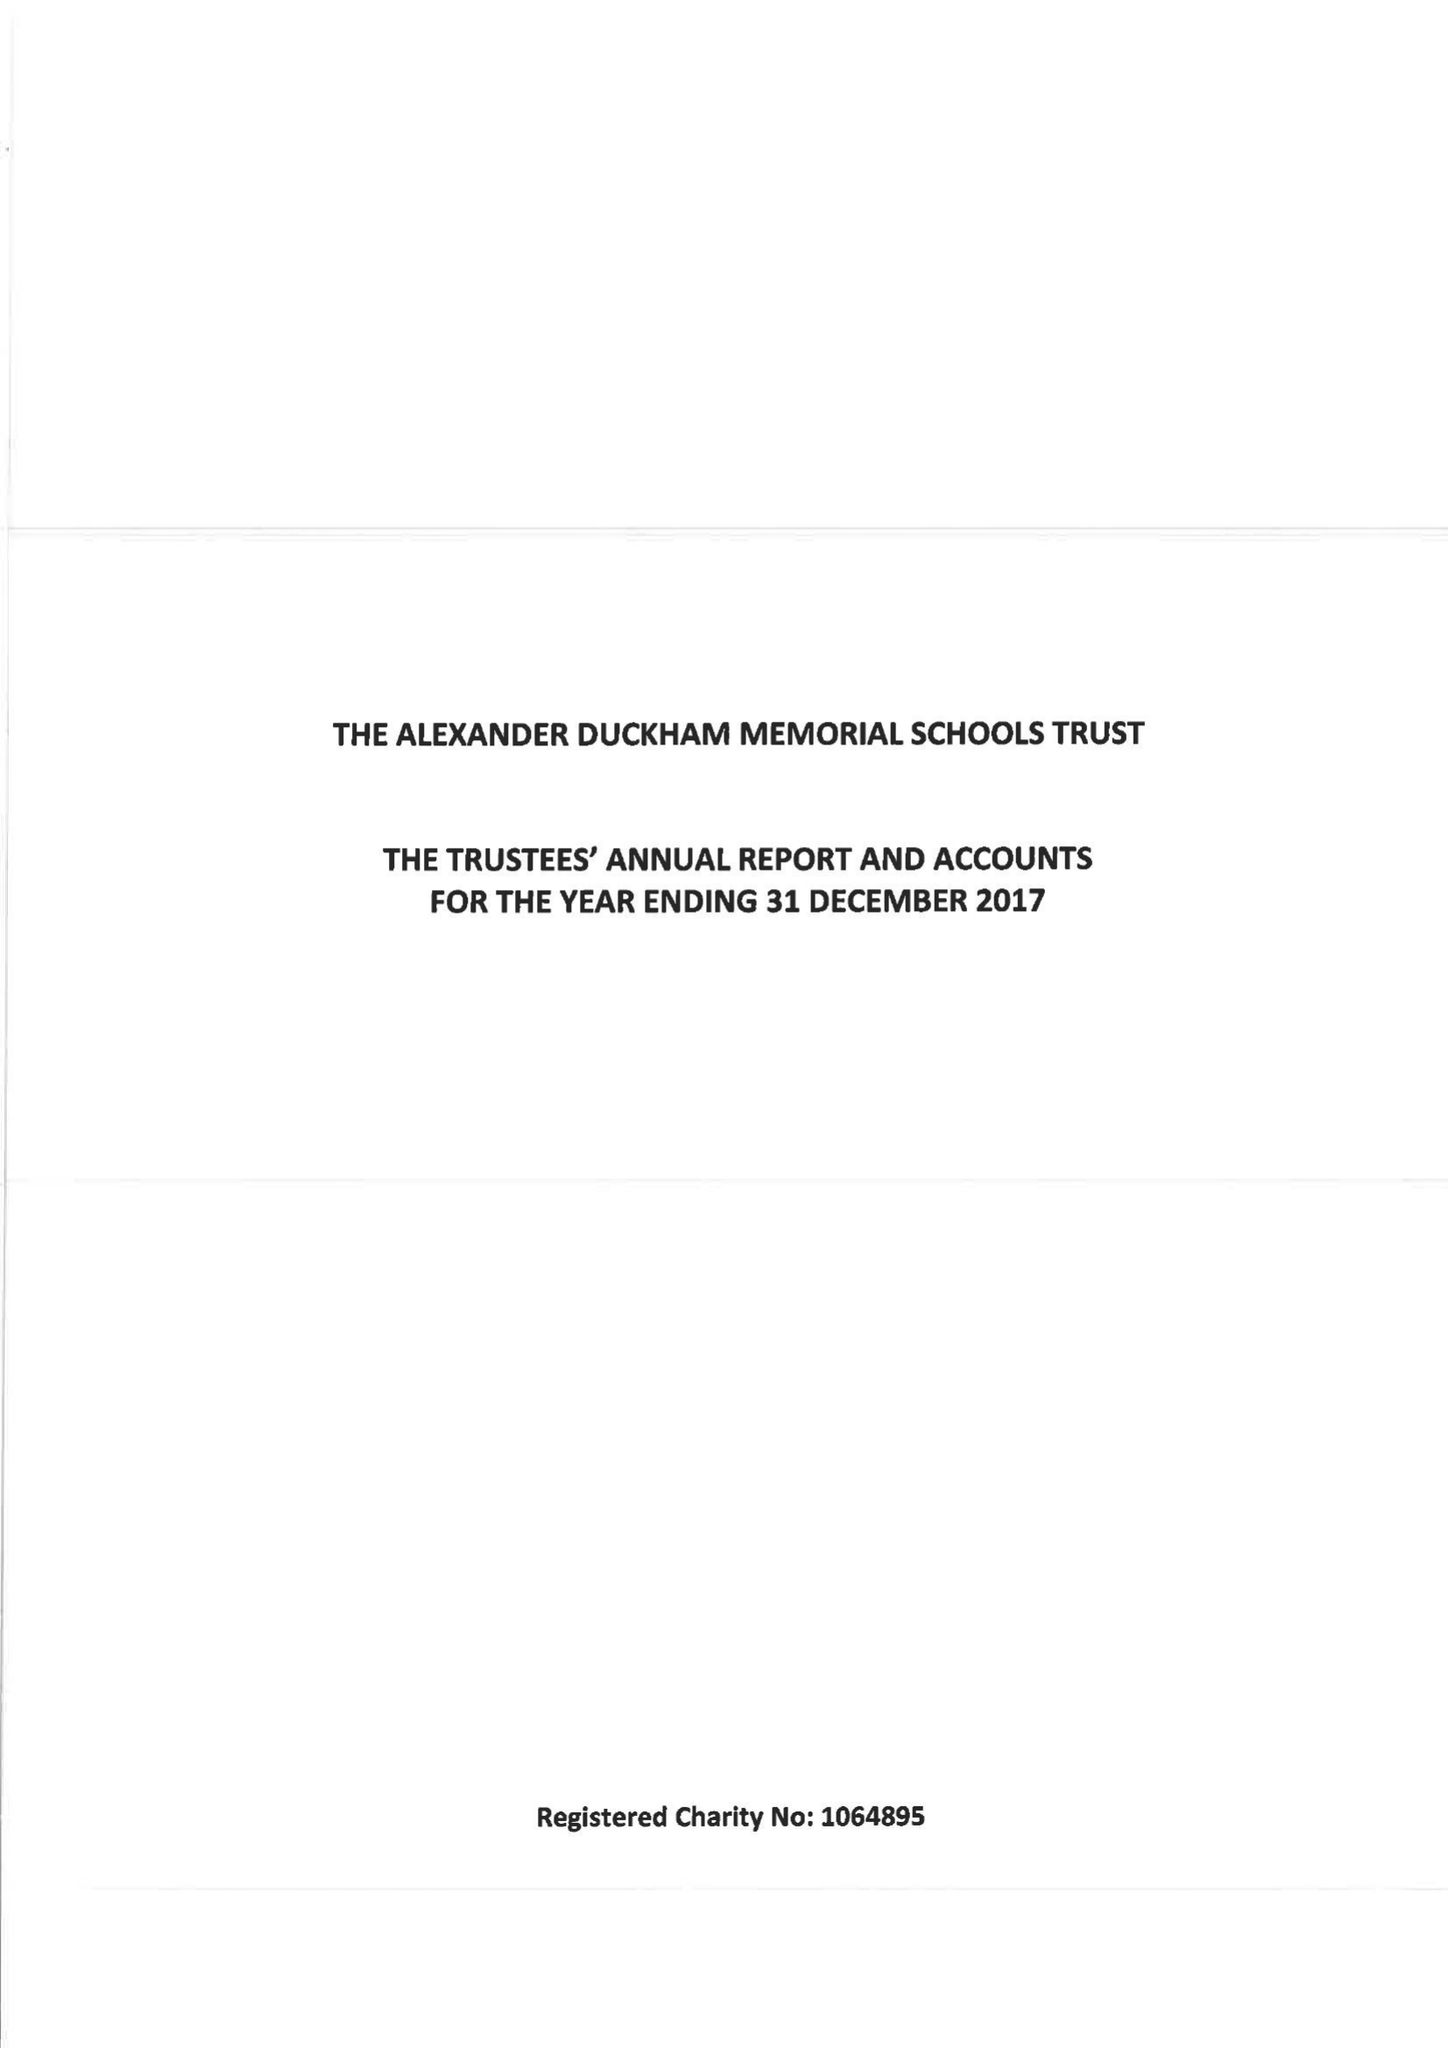What is the value for the address__street_line?
Answer the question using a single word or phrase. None 